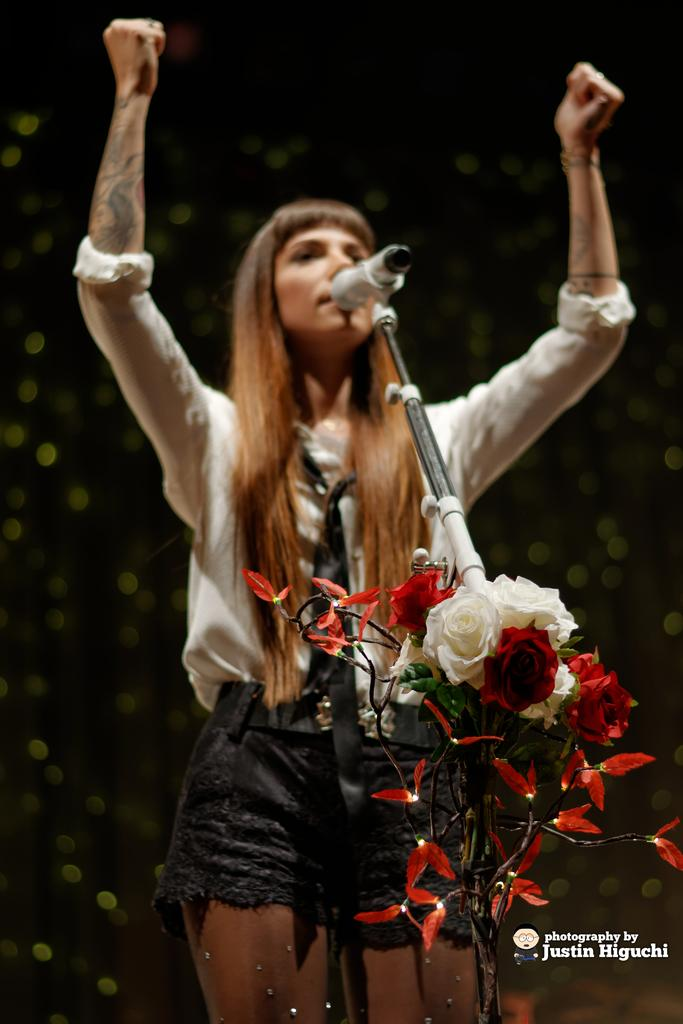Who is the main subject in the image? There is a woman in the image. What is the woman doing in the image? The woman is standing and talking in front of a mic. What can be seen in the front of the image? There are flowers in the front of the image. What is the woman wearing in the image? The woman is wearing a white shirt and black shorts. How many snakes are slithering around the woman's feet in the image? There are no snakes present in the image; the woman is standing near flowers. 